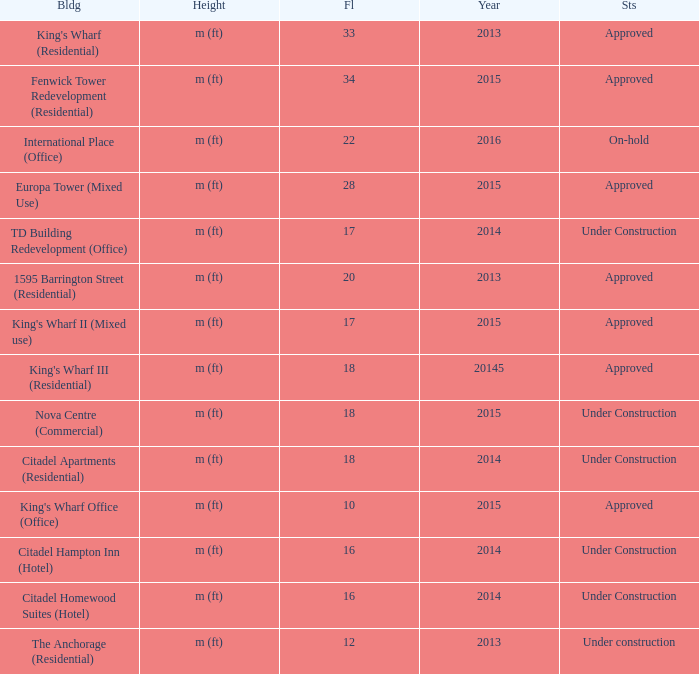What are the number of floors for the building of td building redevelopment (office)? 17.0. 